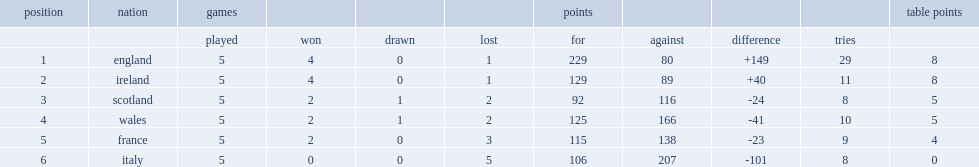Would you be able to parse every entry in this table? {'header': ['position', 'nation', 'games', '', '', '', 'points', '', '', '', 'table points'], 'rows': [['', '', 'played', 'won', 'drawn', 'lost', 'for', 'against', 'difference', 'tries', ''], ['1', 'england', '5', '4', '0', '1', '229', '80', '+149', '29', '8'], ['2', 'ireland', '5', '4', '0', '1', '129', '89', '+40', '11', '8'], ['3', 'scotland', '5', '2', '1', '2', '92', '116', '-24', '8', '5'], ['4', 'wales', '5', '2', '1', '2', '125', '166', '-41', '10', '5'], ['5', 'france', '5', '2', '0', '3', '115', '138', '-23', '9', '4'], ['6', 'italy', '5', '0', '0', '5', '106', '207', '-101', '8', '0']]} Which nation set records for points scored (229), tries scored (29) and points difference (+149)? England. 